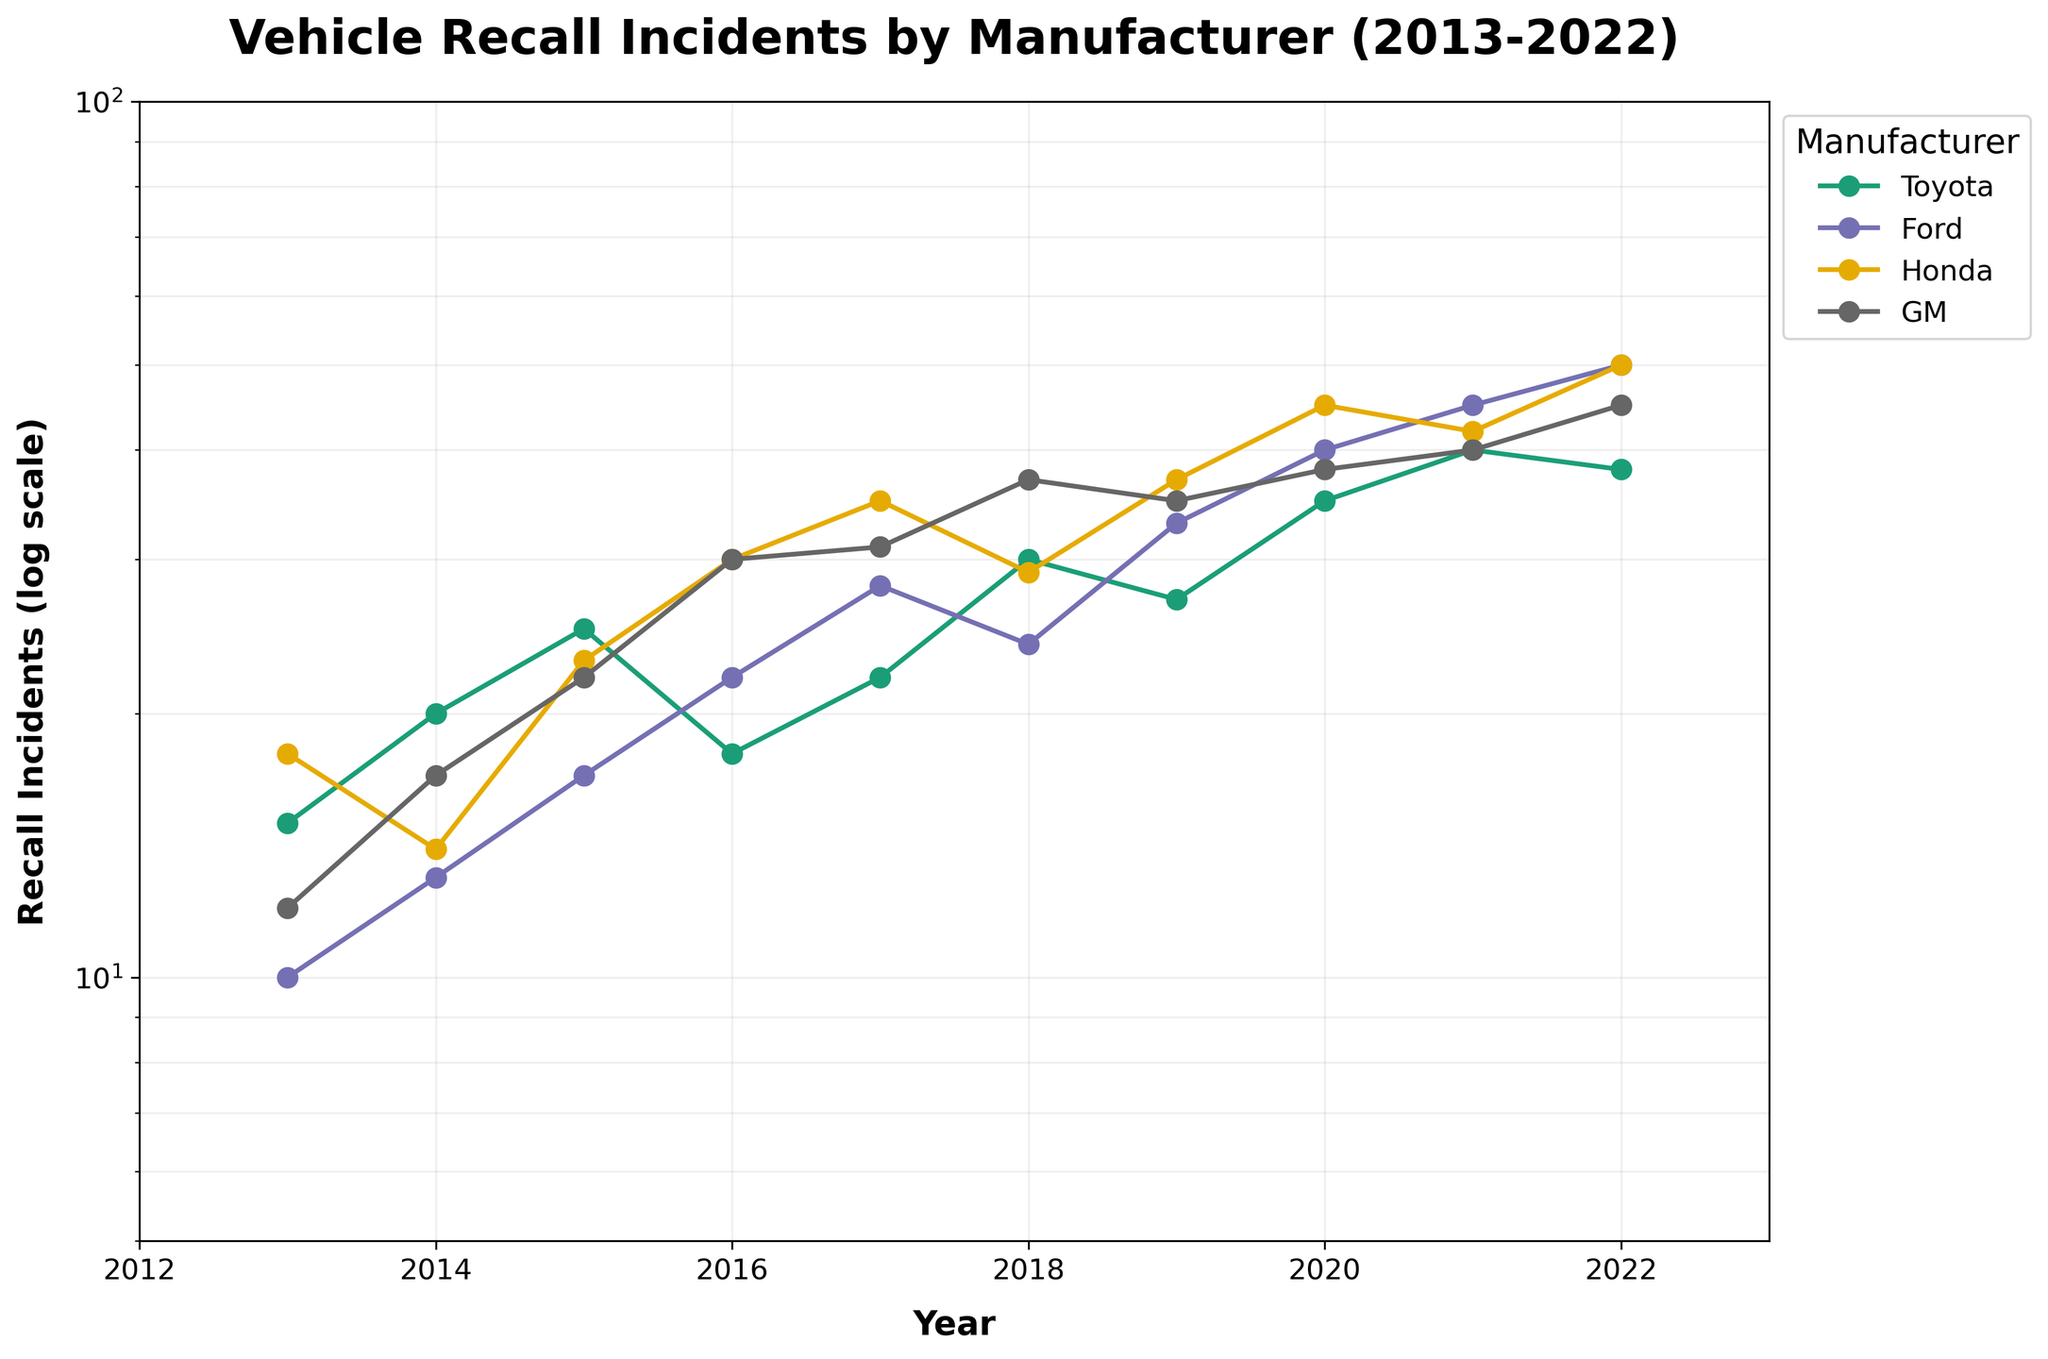What is the title of the figure? The title of the figure is prominently displayed at the top of the plot. It reads "Vehicle Recall Incidents by Manufacturer (2013-2022)."
Answer: Vehicle Recall Incidents by Manufacturer (2013-2022) What is the range of years displayed on the x-axis? The x-axis represents the years, and it ranges from 2013 to 2022. This is confirmed by observing the minimum and maximum values on the x-axis.
Answer: 2013 to 2022 Which manufacturer had the highest number of recall incidents in 2022? To determine the manufacturer with the highest recall incidents in 2022, look at the recall incidents' values for all manufacturers. The line for Ford reaches the highest point in 2022, indicating approximately 50 recall incidents.
Answer: Ford How does the recall incident trend for Honda change from 2013 to 2022? Observing the Honda line reveals an overall increasing trend in recall incidents from 2013 to 2022. It starts at 18 in 2013 and increases, with fluctuations, to around 50 in 2022.
Answer: Increasing trajectory Which manufacturer consistently had the fewest recall incidents over the decade? By examining the lines for each manufacturer, it becomes clear that Toyota generally had lower recall incidents compared to others, predominantly staying below Ford, Honda, and GM through most of the decade.
Answer: Toyota In which year did GM have the largest increase in recall incidents compared to the previous year? To find this, calculate the year-over-year difference for GM and identify the largest increase. The biggest jump appears to be from 2015 (22 incidents) to 2016 (30 incidents), an increase of 8.
Answer: 2016 What was the approximate number of recall incidents for each manufacturer in 2018? Refer to the 2018 marks on the lines for each manufacturer. Toyota had about 30, Ford approximately 24, Honda around 29, and GM about 37 recall incidents in 2018.
Answer: Toyota: 30, Ford: 24, Honda: 29, GM: 37 Is there any year where all manufacturers had increasing recall incidents from the previous year? Examine the trends for each manufacturer year-over-year. In 2020, all four manufacturers (Toyota, Ford, Honda, GM) had more recall incidents than they did in 2019.
Answer: 2020 How many manufacturers had recall incidents that cross 40 in any year? Look at the lines to see instances where any manufacturer had recall incidents exceeding 40. Both Ford and Honda crossed 40 in varying years (2020 onwards), as did GM in 2022.
Answer: 3 manufacturers 